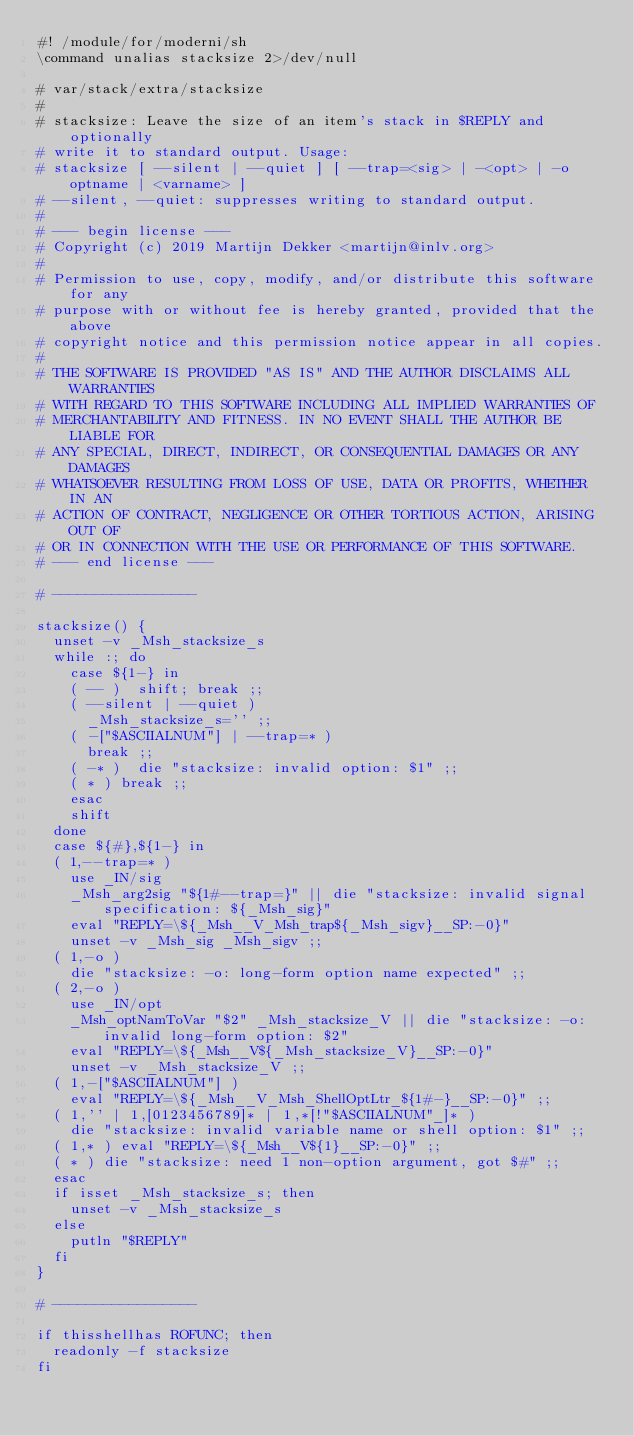<code> <loc_0><loc_0><loc_500><loc_500><_ObjectiveC_>#! /module/for/moderni/sh
\command unalias stacksize 2>/dev/null

# var/stack/extra/stacksize
#
# stacksize: Leave the size of an item's stack in $REPLY and optionally
# write it to standard output. Usage:
#	stacksize [ --silent | --quiet ] [ --trap=<sig> | -<opt> | -o optname | <varname> ]
# --silent, --quiet: suppresses writing to standard output.
#
# --- begin license ---
# Copyright (c) 2019 Martijn Dekker <martijn@inlv.org>
#
# Permission to use, copy, modify, and/or distribute this software for any
# purpose with or without fee is hereby granted, provided that the above
# copyright notice and this permission notice appear in all copies.
#
# THE SOFTWARE IS PROVIDED "AS IS" AND THE AUTHOR DISCLAIMS ALL WARRANTIES
# WITH REGARD TO THIS SOFTWARE INCLUDING ALL IMPLIED WARRANTIES OF
# MERCHANTABILITY AND FITNESS. IN NO EVENT SHALL THE AUTHOR BE LIABLE FOR
# ANY SPECIAL, DIRECT, INDIRECT, OR CONSEQUENTIAL DAMAGES OR ANY DAMAGES
# WHATSOEVER RESULTING FROM LOSS OF USE, DATA OR PROFITS, WHETHER IN AN
# ACTION OF CONTRACT, NEGLIGENCE OR OTHER TORTIOUS ACTION, ARISING OUT OF
# OR IN CONNECTION WITH THE USE OR PERFORMANCE OF THIS SOFTWARE.
# --- end license ---

# -----------------

stacksize() {
	unset -v _Msh_stacksize_s
	while :; do
		case ${1-} in
		( -- )	shift; break ;;
		( --silent | --quiet )
			_Msh_stacksize_s='' ;;
		( -["$ASCIIALNUM"] | --trap=* )
			break ;;
		( -* )	die "stacksize: invalid option: $1" ;;
		( * )	break ;;
		esac
		shift
	done
	case ${#},${1-} in
	( 1,--trap=* )
		use _IN/sig
		_Msh_arg2sig "${1#--trap=}" || die "stacksize: invalid signal specification: ${_Msh_sig}"
		eval "REPLY=\${_Msh__V_Msh_trap${_Msh_sigv}__SP:-0}"
		unset -v _Msh_sig _Msh_sigv ;;
	( 1,-o )
		die "stacksize: -o: long-form option name expected" ;;
	( 2,-o )
		use _IN/opt
		_Msh_optNamToVar "$2" _Msh_stacksize_V || die "stacksize: -o: invalid long-form option: $2"
		eval "REPLY=\${_Msh__V${_Msh_stacksize_V}__SP:-0}"
		unset -v _Msh_stacksize_V ;;
	( 1,-["$ASCIIALNUM"] )
		eval "REPLY=\${_Msh__V_Msh_ShellOptLtr_${1#-}__SP:-0}" ;;
	( 1,'' | 1,[0123456789]* | 1,*[!"$ASCIIALNUM"_]* )
		die "stacksize: invalid variable name or shell option: $1" ;;
	( 1,* )	eval "REPLY=\${_Msh__V${1}__SP:-0}" ;;
	( * )	die "stacksize: need 1 non-option argument, got $#" ;;
	esac
	if isset _Msh_stacksize_s; then
		unset -v _Msh_stacksize_s
	else
		putln "$REPLY"
	fi
}

# -----------------

if thisshellhas ROFUNC; then
	readonly -f stacksize
fi
</code> 